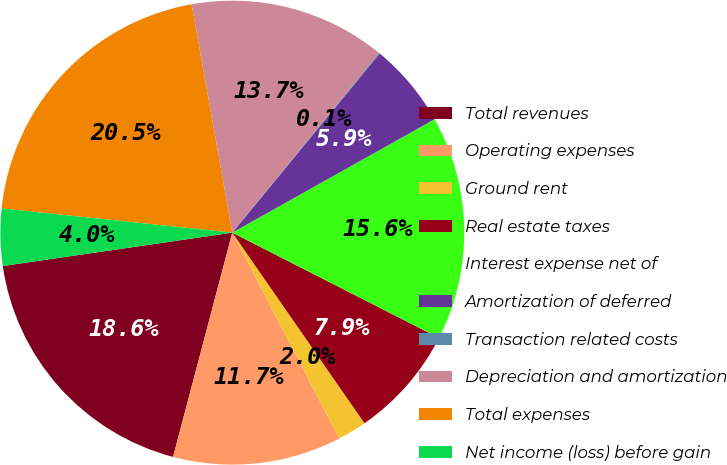<chart> <loc_0><loc_0><loc_500><loc_500><pie_chart><fcel>Total revenues<fcel>Operating expenses<fcel>Ground rent<fcel>Real estate taxes<fcel>Interest expense net of<fcel>Amortization of deferred<fcel>Transaction related costs<fcel>Depreciation and amortization<fcel>Total expenses<fcel>Net income (loss) before gain<nl><fcel>18.59%<fcel>11.74%<fcel>2.02%<fcel>7.85%<fcel>15.63%<fcel>5.91%<fcel>0.07%<fcel>13.69%<fcel>20.53%<fcel>3.96%<nl></chart> 